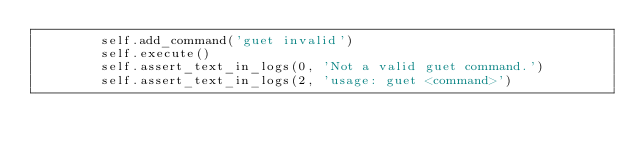<code> <loc_0><loc_0><loc_500><loc_500><_Python_>        self.add_command('guet invalid')
        self.execute()
        self.assert_text_in_logs(0, 'Not a valid guet command.')
        self.assert_text_in_logs(2, 'usage: guet <command>')
</code> 